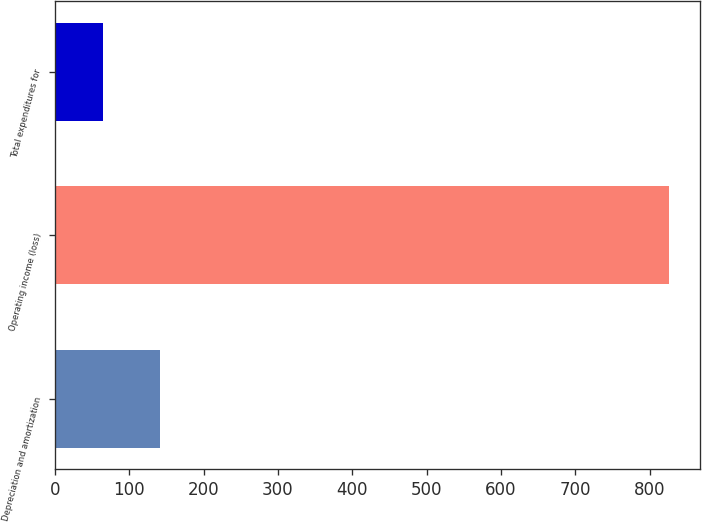Convert chart to OTSL. <chart><loc_0><loc_0><loc_500><loc_500><bar_chart><fcel>Depreciation and amortization<fcel>Operating income (loss)<fcel>Total expenditures for<nl><fcel>141.1<fcel>826<fcel>65<nl></chart> 